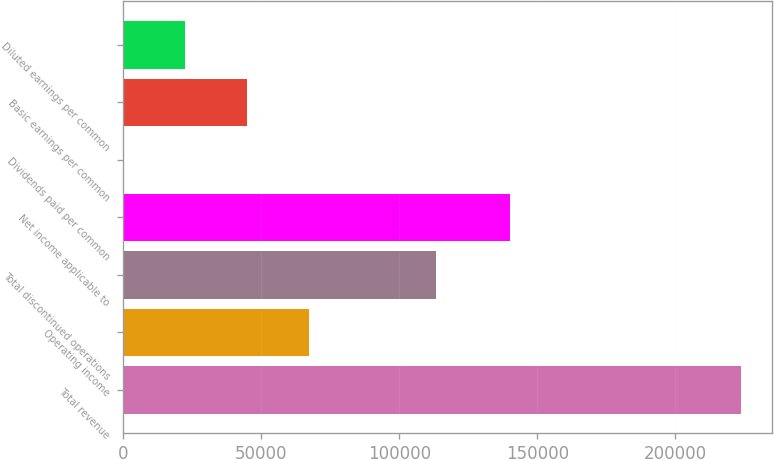Convert chart. <chart><loc_0><loc_0><loc_500><loc_500><bar_chart><fcel>Total revenue<fcel>Operating income<fcel>Total discontinued operations<fcel>Net income applicable to<fcel>Dividends paid per common<fcel>Basic earnings per common<fcel>Diluted earnings per common<nl><fcel>223749<fcel>67125<fcel>113267<fcel>140005<fcel>0.45<fcel>44750.2<fcel>22375.3<nl></chart> 